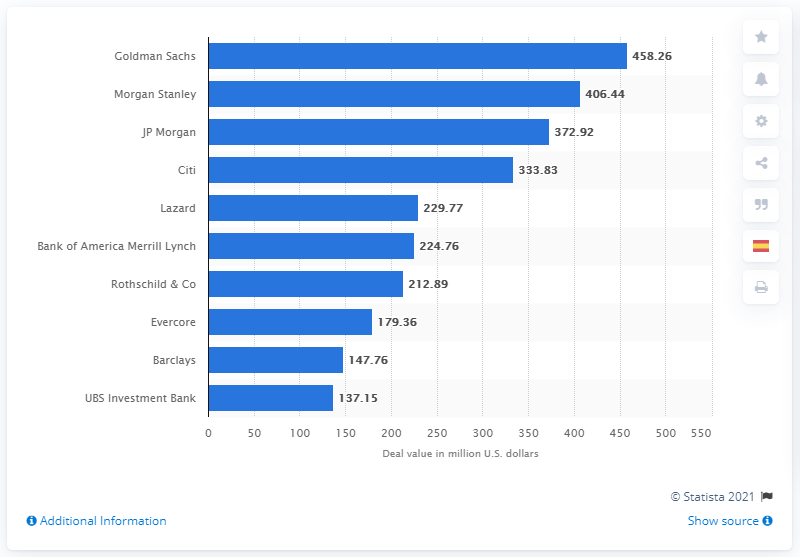Identify some key points in this picture. In 2018, the total deal value for Goldman Sachs was approximately $458.26. In 2018, Goldman Sachs was the leading advisor for M&A deals in Europe. 